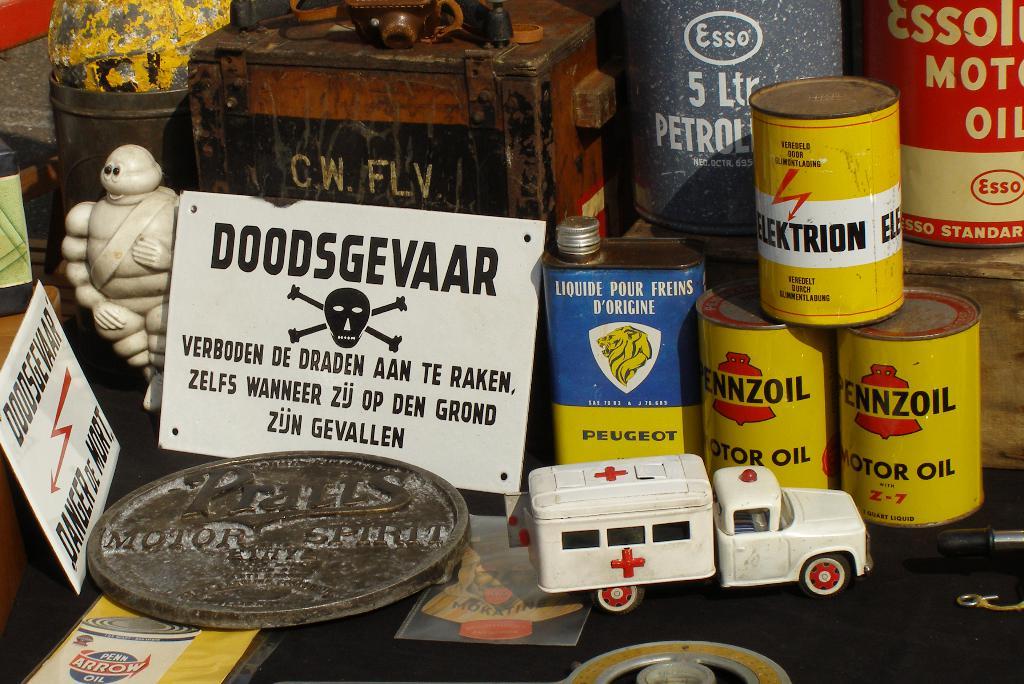What is the text above the skull and crossbones?
Ensure brevity in your answer.  Doodsgevaar. 